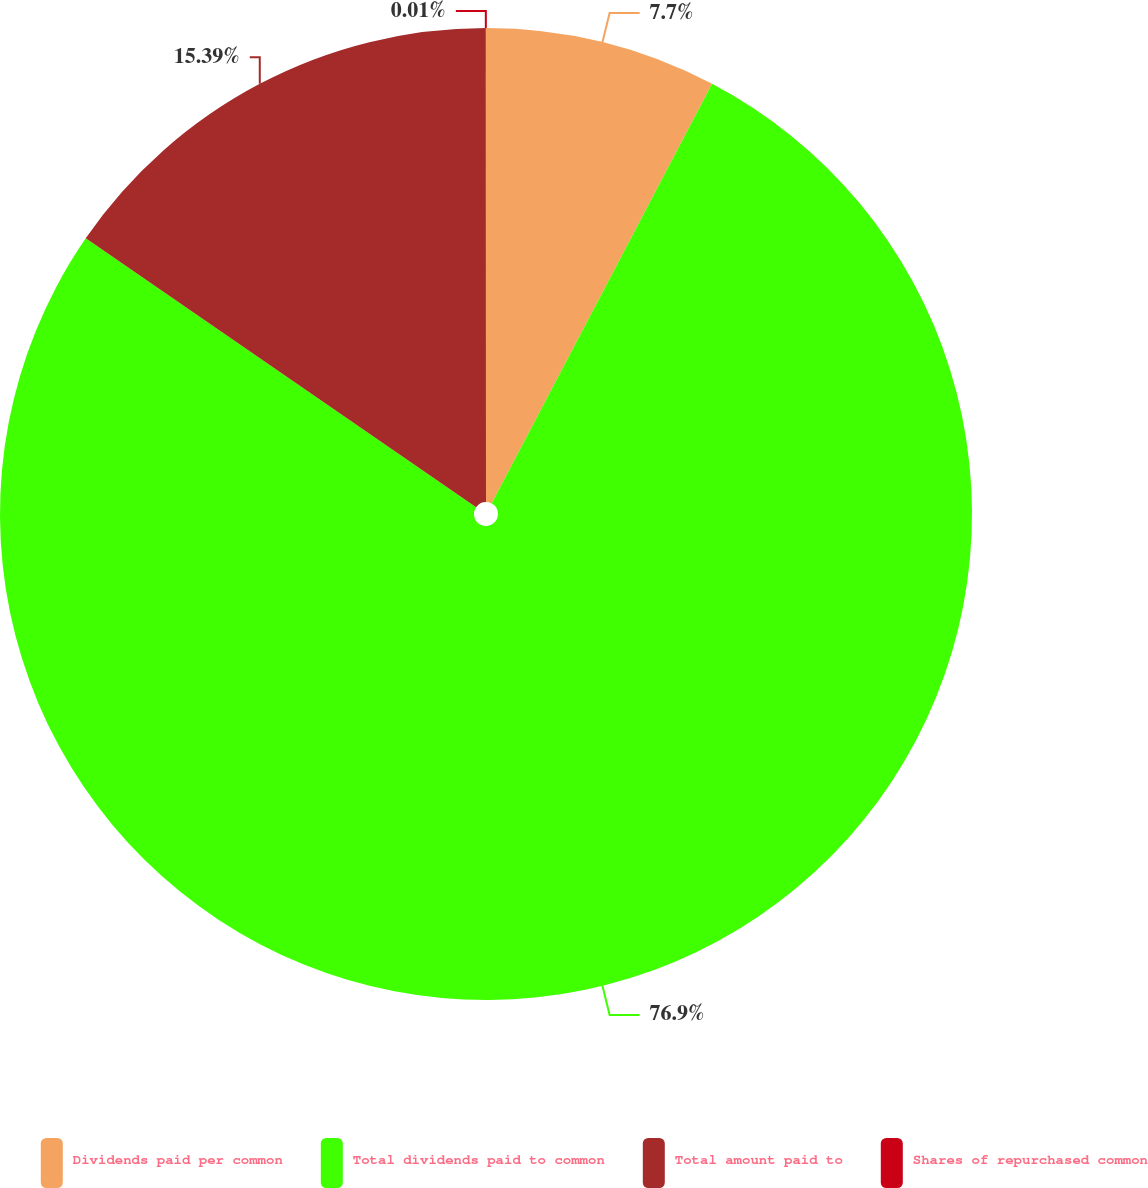Convert chart. <chart><loc_0><loc_0><loc_500><loc_500><pie_chart><fcel>Dividends paid per common<fcel>Total dividends paid to common<fcel>Total amount paid to<fcel>Shares of repurchased common<nl><fcel>7.7%<fcel>76.89%<fcel>15.39%<fcel>0.01%<nl></chart> 